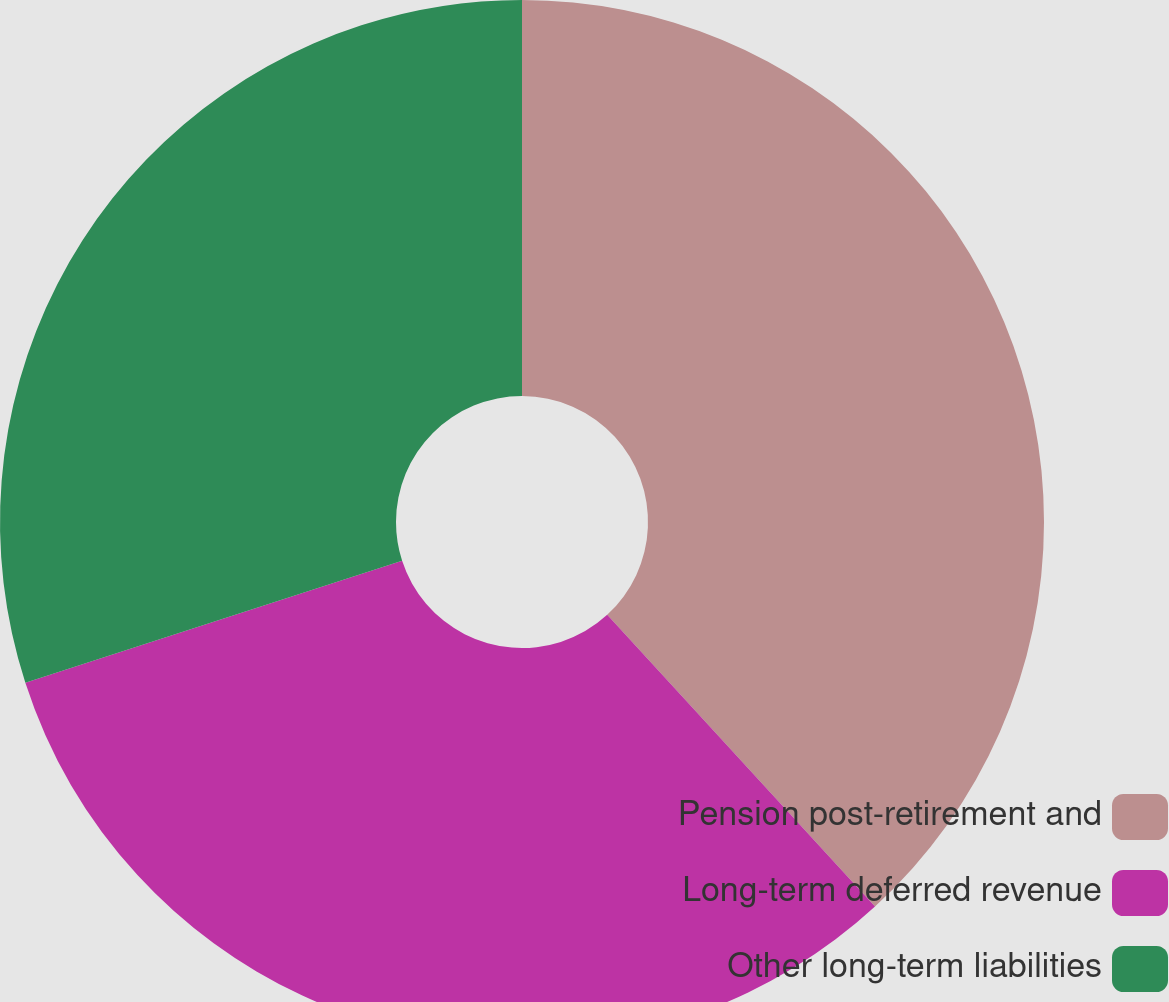<chart> <loc_0><loc_0><loc_500><loc_500><pie_chart><fcel>Pension post-retirement and<fcel>Long-term deferred revenue<fcel>Other long-term liabilities<nl><fcel>38.18%<fcel>31.84%<fcel>29.98%<nl></chart> 